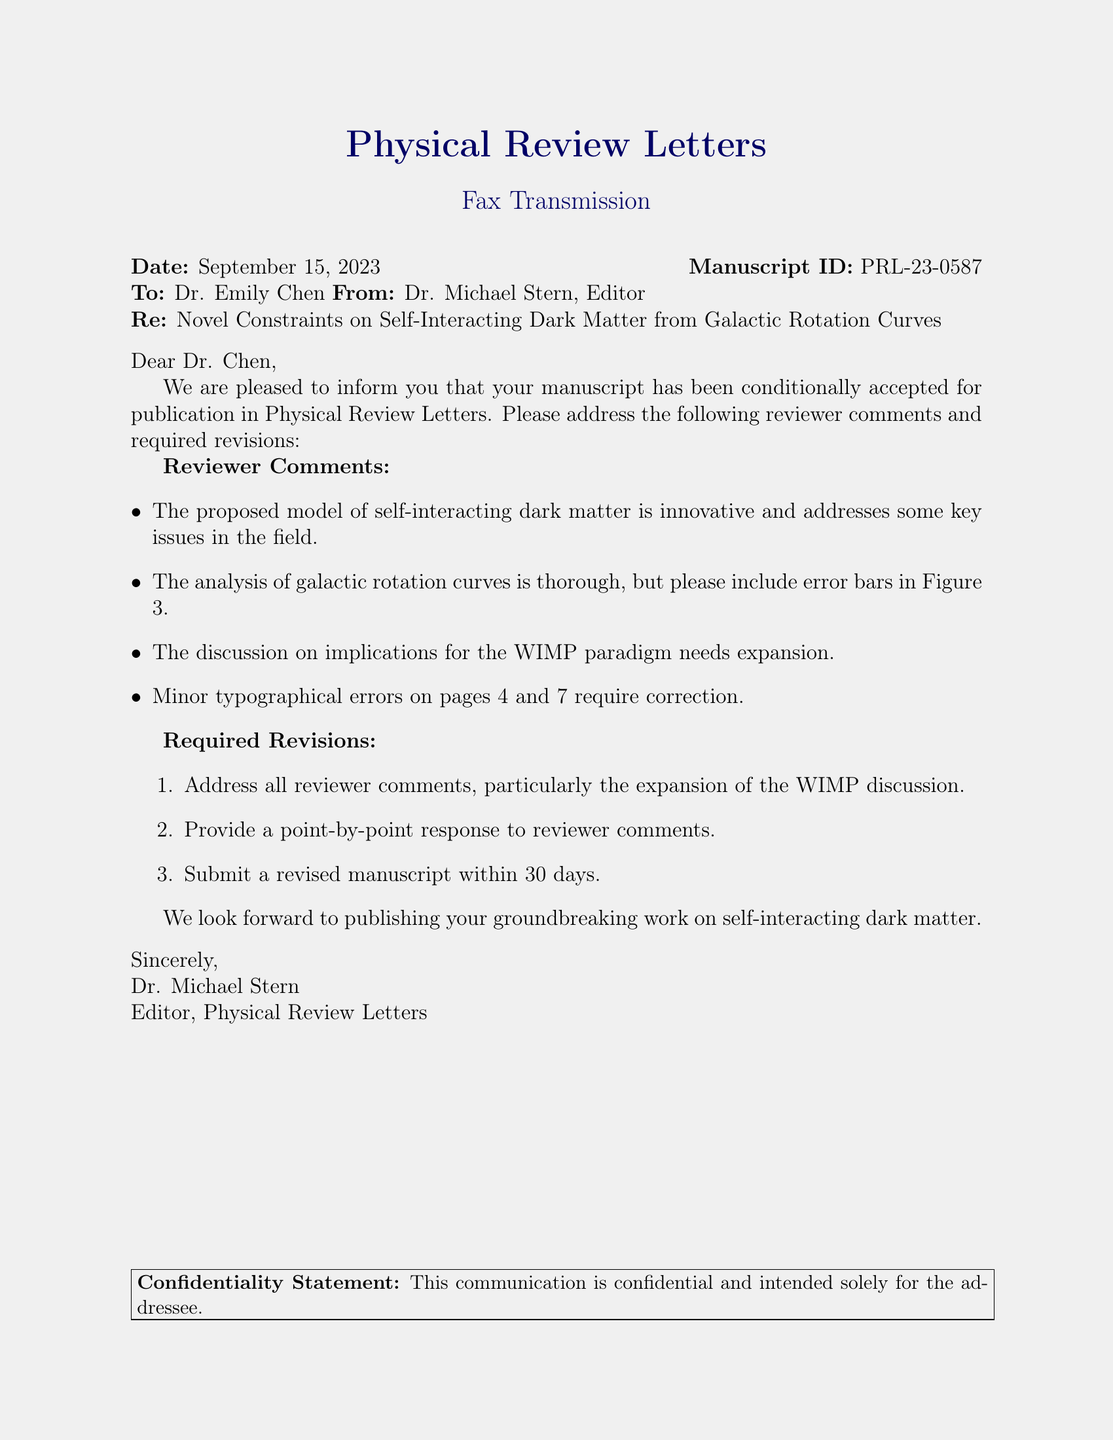What is the date of the fax? The date given in the fax is the date of communication regarding the manuscript.
Answer: September 15, 2023 Who is the editor of the journal? The signature at the bottom of the fax identifies the person who sent the communication and their role.
Answer: Dr. Michael Stern What is the title of the manuscript? The subject of the fax indicates the specific focus and content of the accepted manuscript.
Answer: Novel Constraints on Self-Interacting Dark Matter from Galactic Rotation Curves What is the manuscript ID? The manuscript ID is a unique identifier for tracking and referencing the manuscript within the journal's system.
Answer: PRL-23-0587 What revisions are required by the reviewers? The required revisions are listed under a specific section, detailing what the author needs to address in the manuscript.
Answer: Address all reviewer comments What is one error that needs correction in the manuscript? Specific suggestions for corrections are provided in the reviewer comments section.
Answer: Typographical errors How many days does the author have to submit the revised manuscript? The fax specifies a time frame for revisions to be completed and submitted.
Answer: 30 days How many reviewer comments are there? The document mentions a series of comments from reviewers regarding the manuscript.
Answer: Four What does the review suggest about the proposed model? The reviewer comments provide an assessment of the proposed model's significance in the field.
Answer: Innovative What implication should the author expand upon in their revision? The requirement specifies a particular discussion area that the author needs to elaborate on in the revision.
Answer: WIMP paradigm 